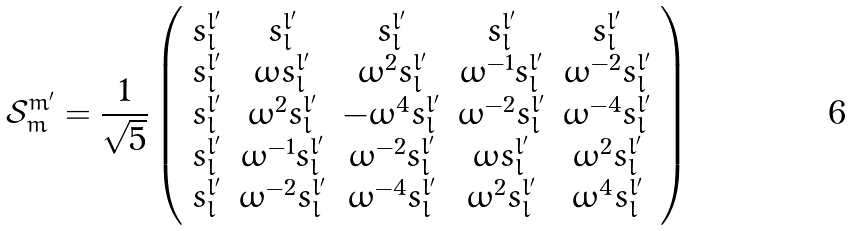Convert formula to latex. <formula><loc_0><loc_0><loc_500><loc_500>\mathcal { S } ^ { m ^ { \prime } } _ { m } = \frac { 1 } { \sqrt { 5 } } \left ( \begin{array} { c c c c c } s ^ { l ^ { \prime } } _ { l } & s ^ { l ^ { \prime } } _ { l } & s ^ { l ^ { \prime } } _ { l } & s ^ { l ^ { \prime } } _ { l } & s ^ { l ^ { \prime } } _ { l } \\ s ^ { l ^ { \prime } } _ { l } & \omega s ^ { l ^ { \prime } } _ { l } & \omega ^ { 2 } s ^ { l ^ { \prime } } _ { l } & \omega ^ { - 1 } s ^ { l ^ { \prime } } _ { l } & \omega ^ { - 2 } s ^ { l ^ { \prime } } _ { l } \\ s ^ { l ^ { \prime } } _ { l } & \omega ^ { 2 } s ^ { l ^ { \prime } } _ { l } & - \omega ^ { 4 } s ^ { l ^ { \prime } } _ { l } & \omega ^ { - 2 } s ^ { l ^ { \prime } } _ { l } & \omega ^ { - 4 } s ^ { l ^ { \prime } } _ { l } \\ s ^ { l ^ { \prime } } _ { l } & \omega ^ { - 1 } s ^ { l ^ { \prime } } _ { l } & \omega ^ { - 2 } s ^ { l ^ { \prime } } _ { l } & \omega s ^ { l ^ { \prime } } _ { l } & \omega ^ { 2 } s ^ { l ^ { \prime } } _ { l } \\ s ^ { l ^ { \prime } } _ { l } & \omega ^ { - 2 } s ^ { l ^ { \prime } } _ { l } & \omega ^ { - 4 } s ^ { l ^ { \prime } } _ { l } & \omega ^ { 2 } s ^ { l ^ { \prime } } _ { l } & \omega ^ { 4 } s ^ { l ^ { \prime } } _ { l } \end{array} \right )</formula> 